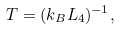<formula> <loc_0><loc_0><loc_500><loc_500>T = ( k _ { B } L _ { 4 } ) ^ { - 1 } ,</formula> 